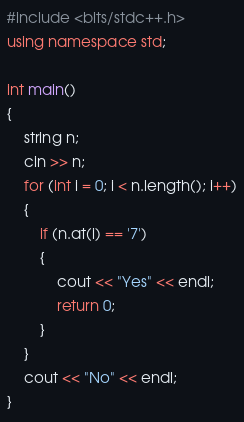Convert code to text. <code><loc_0><loc_0><loc_500><loc_500><_C++_>#include <bits/stdc++.h>
using namespace std;

int main()
{
    string n;
    cin >> n;
    for (int i = 0; i < n.length(); i++)
    {
        if (n.at(i) == '7')
        {
            cout << "Yes" << endl;
            return 0;
        }
    }
    cout << "No" << endl;
}</code> 